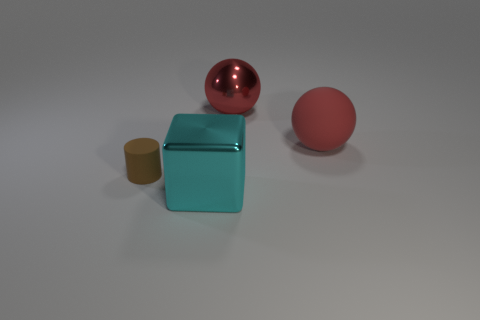What number of spheres have the same size as the cyan cube?
Give a very brief answer. 2. Do the big metal object to the right of the big cyan metal cube and the rubber cylinder to the left of the cyan metallic thing have the same color?
Offer a very short reply. No. What number of large red balls are left of the red metal ball?
Your response must be concise. 0. There is a shiny thing that is the same color as the large matte thing; what size is it?
Ensure brevity in your answer.  Large. Is there a big metallic thing that has the same shape as the tiny matte object?
Provide a succinct answer. No. There is a block that is the same size as the metal ball; what color is it?
Make the answer very short. Cyan. Are there fewer red metal objects that are behind the small brown matte thing than large objects that are behind the big cyan object?
Keep it short and to the point. Yes. There is a rubber thing on the right side of the brown matte object; is its size the same as the small rubber object?
Ensure brevity in your answer.  No. There is a metal thing in front of the cylinder; what is its shape?
Offer a terse response. Cube. Is the number of small brown things greater than the number of metallic objects?
Your response must be concise. No. 